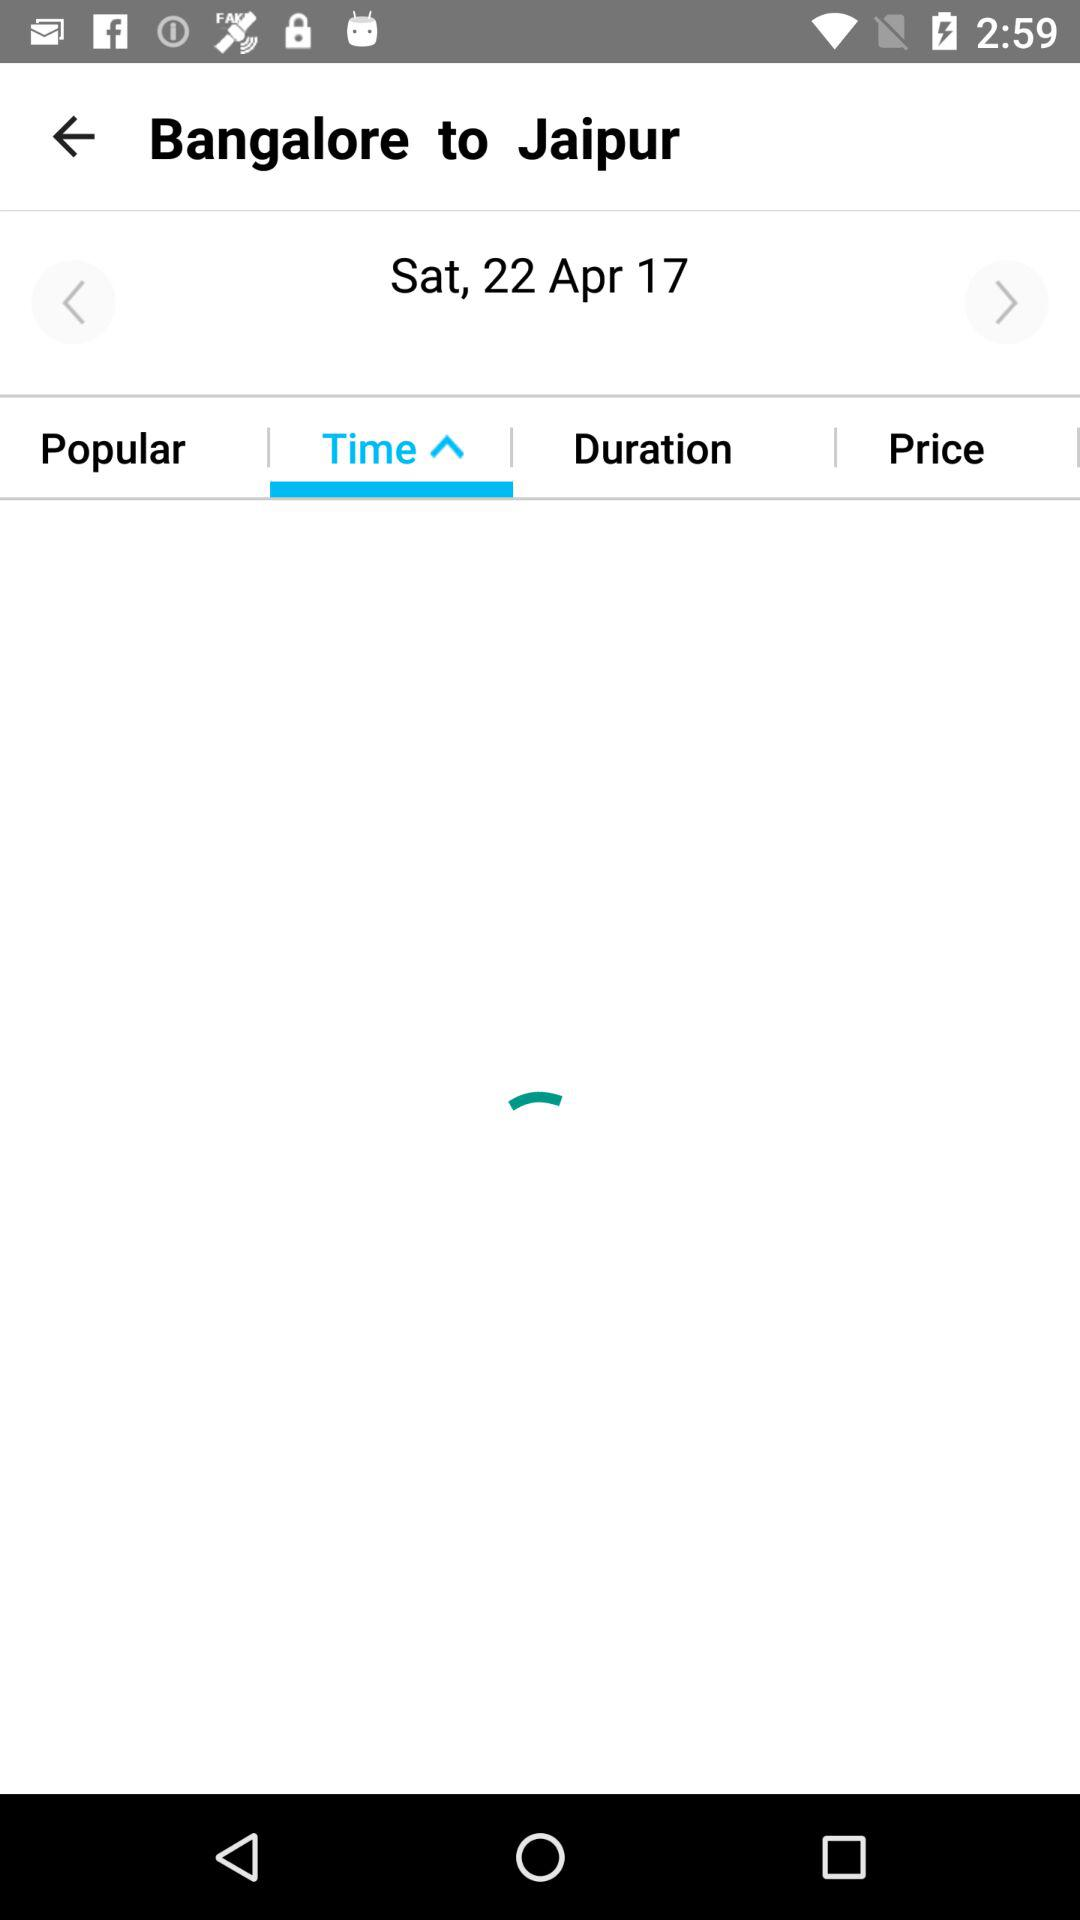What's the scheduled date? The scheduled date is Saturday, April 22, 2017. 